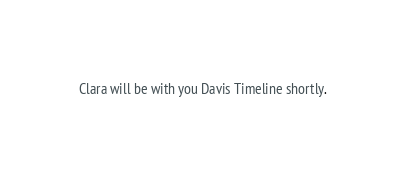<code> <loc_0><loc_0><loc_500><loc_500><_FORTRAN_>Clara will be with you Davis Timeline shortly.
</code> 